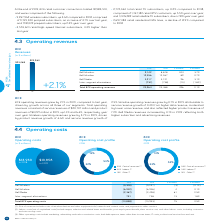According to Bce's financial document, What does the cost of revenues include? Cost of revenues includes costs of wireless devices and other equipment sold, network and content costs, and payments to other carriers.. The document states: "(1) Cost of revenues includes costs of wireless devices and other equipment sold, network and content costs, and payments to other carriers...." Also, What is the percentage change for Bell Wireline? According to the financial document, 0.1%. The relevant text states: "Bell Wireless (5,300) (5,297) (3) (0.1%)..." Also, What are the Inter-segment eliminations in 2018? According to the financial document, 738. The relevant text states: "Inter-segment eliminations 751 738 13 1.8%..." Also, can you calculate: What is the sum of Inter-segment eliminations in 2018 and 2019? Based on the calculation: 751+738, the result is 1489. This is based on the information: "Inter-segment eliminations 751 738 13 1.8% Inter-segment eliminations 751 738 13 1.8%..." The key data points involved are: 738, 751. Additionally, Which segment has the largest $ change? According to the financial document, Bell Media. The relevant text states: "Bell Media (2,367) (2,428) 61 2.5%..." Also, can you calculate: What is the percentage of the costs incurred by Bell Wireline out of the total BCE operating costs in 2019? To answer this question, I need to perform calculations using the financial data. The calculation is: -6,942/-13,858, which equals 50.09 (percentage). This is based on the information: "Bell Wireline (6,942) (6,946) 4 0.1% Total BCE operating costs (13,858) (13,933) 75 0.5%..." The key data points involved are: 13,858, 6,942. 